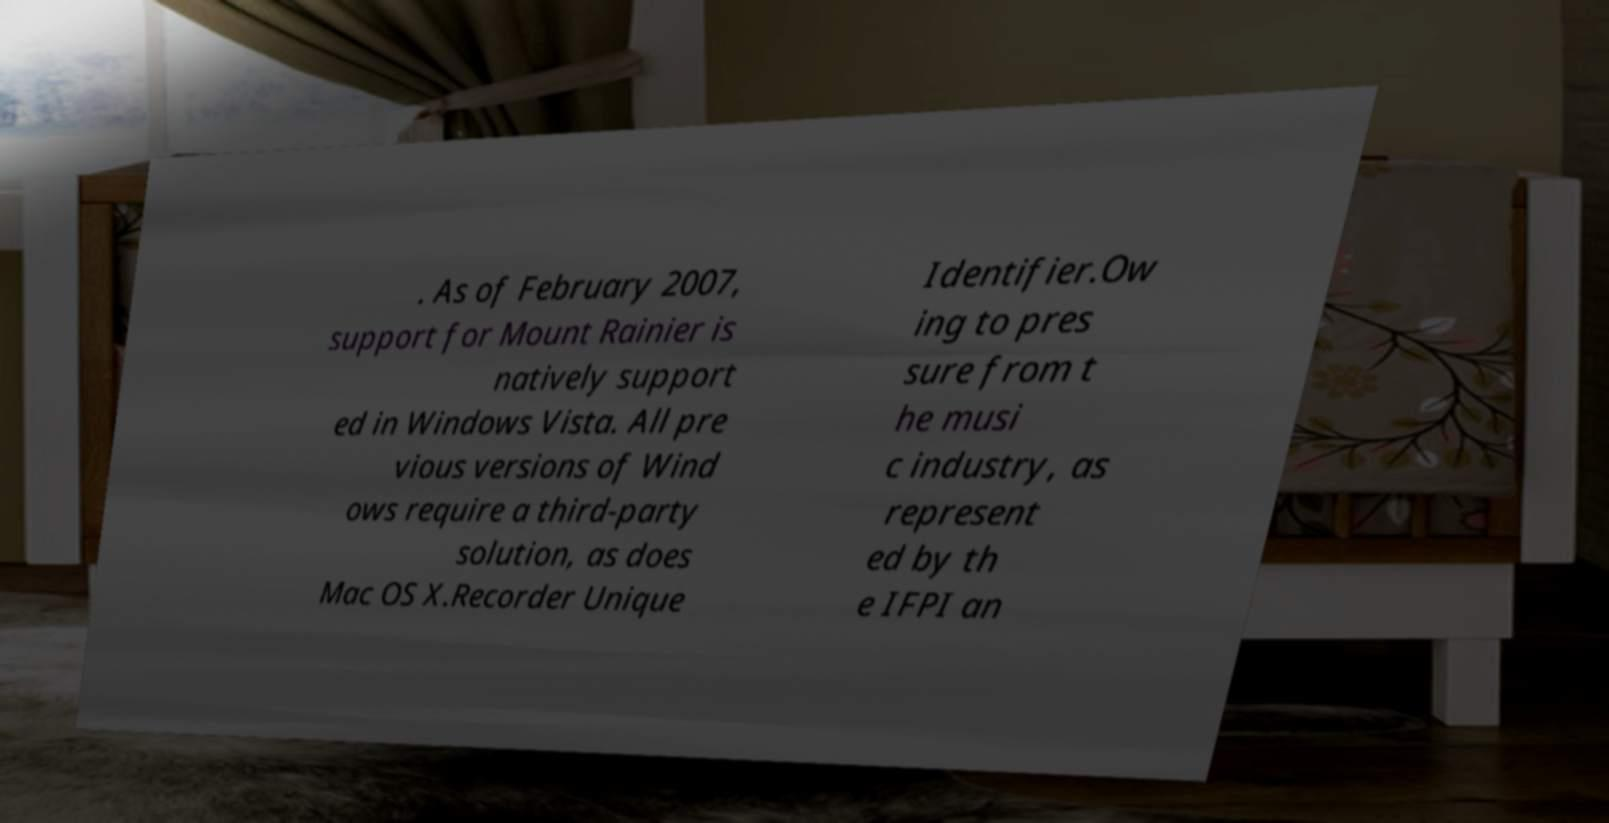What messages or text are displayed in this image? I need them in a readable, typed format. . As of February 2007, support for Mount Rainier is natively support ed in Windows Vista. All pre vious versions of Wind ows require a third-party solution, as does Mac OS X.Recorder Unique Identifier.Ow ing to pres sure from t he musi c industry, as represent ed by th e IFPI an 